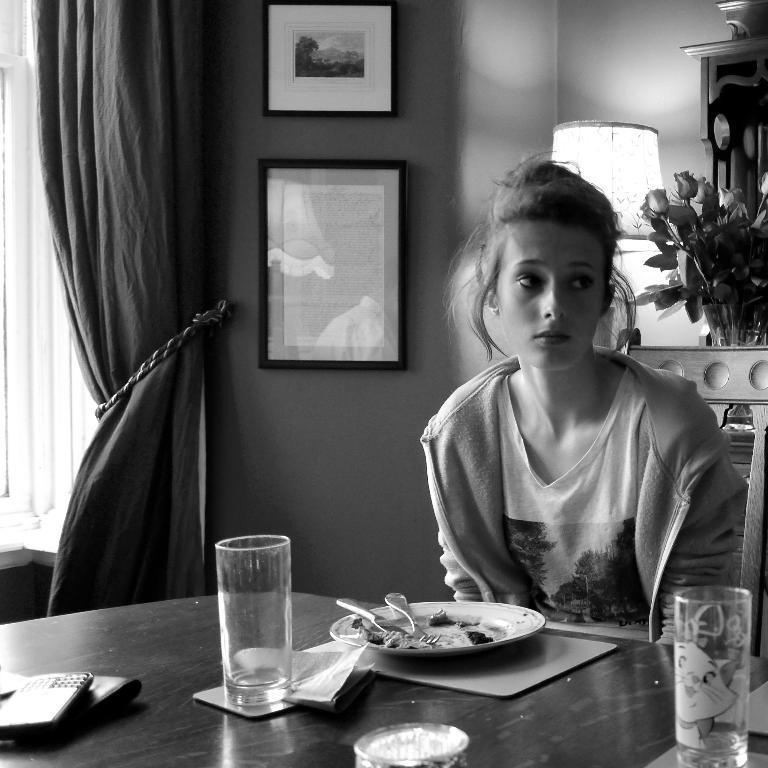How would you summarize this image in a sentence or two? This is a picture of a woman seated in a chair on a dining table. On the table there is a glass, plate, spoon, mobile. On the top right there is a bouquet, lamp. In the center of the background there are frames. On the top left there is window and a curtain. 